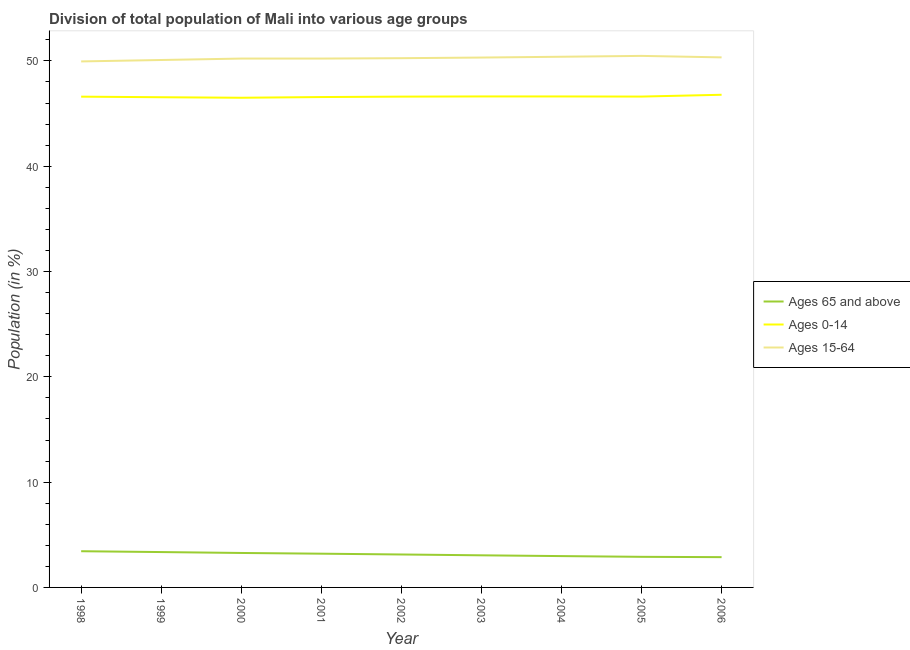Does the line corresponding to percentage of population within the age-group 0-14 intersect with the line corresponding to percentage of population within the age-group of 65 and above?
Provide a succinct answer. No. What is the percentage of population within the age-group of 65 and above in 2000?
Ensure brevity in your answer.  3.27. Across all years, what is the maximum percentage of population within the age-group 0-14?
Make the answer very short. 46.79. Across all years, what is the minimum percentage of population within the age-group 0-14?
Offer a very short reply. 46.5. In which year was the percentage of population within the age-group 15-64 minimum?
Keep it short and to the point. 1998. What is the total percentage of population within the age-group 0-14 in the graph?
Ensure brevity in your answer.  419.5. What is the difference between the percentage of population within the age-group 0-14 in 2005 and that in 2006?
Keep it short and to the point. -0.17. What is the difference between the percentage of population within the age-group 15-64 in 2004 and the percentage of population within the age-group of 65 and above in 1998?
Offer a terse response. 46.96. What is the average percentage of population within the age-group of 65 and above per year?
Give a very brief answer. 3.13. In the year 2003, what is the difference between the percentage of population within the age-group of 65 and above and percentage of population within the age-group 15-64?
Give a very brief answer. -47.27. In how many years, is the percentage of population within the age-group 0-14 greater than 36 %?
Keep it short and to the point. 9. What is the ratio of the percentage of population within the age-group 15-64 in 1999 to that in 2004?
Give a very brief answer. 0.99. Is the difference between the percentage of population within the age-group 15-64 in 2002 and 2006 greater than the difference between the percentage of population within the age-group of 65 and above in 2002 and 2006?
Offer a very short reply. No. What is the difference between the highest and the second highest percentage of population within the age-group 0-14?
Keep it short and to the point. 0.16. What is the difference between the highest and the lowest percentage of population within the age-group 15-64?
Keep it short and to the point. 0.53. In how many years, is the percentage of population within the age-group 15-64 greater than the average percentage of population within the age-group 15-64 taken over all years?
Keep it short and to the point. 5. Is it the case that in every year, the sum of the percentage of population within the age-group of 65 and above and percentage of population within the age-group 0-14 is greater than the percentage of population within the age-group 15-64?
Your response must be concise. No. How many years are there in the graph?
Give a very brief answer. 9. Are the values on the major ticks of Y-axis written in scientific E-notation?
Ensure brevity in your answer.  No. Where does the legend appear in the graph?
Ensure brevity in your answer.  Center right. How many legend labels are there?
Ensure brevity in your answer.  3. What is the title of the graph?
Give a very brief answer. Division of total population of Mali into various age groups
. What is the Population (in %) of Ages 65 and above in 1998?
Ensure brevity in your answer.  3.44. What is the Population (in %) in Ages 0-14 in 1998?
Ensure brevity in your answer.  46.61. What is the Population (in %) in Ages 15-64 in 1998?
Offer a very short reply. 49.95. What is the Population (in %) of Ages 65 and above in 1999?
Make the answer very short. 3.36. What is the Population (in %) in Ages 0-14 in 1999?
Your answer should be very brief. 46.55. What is the Population (in %) in Ages 15-64 in 1999?
Ensure brevity in your answer.  50.09. What is the Population (in %) in Ages 65 and above in 2000?
Ensure brevity in your answer.  3.27. What is the Population (in %) in Ages 0-14 in 2000?
Your answer should be very brief. 46.5. What is the Population (in %) in Ages 15-64 in 2000?
Ensure brevity in your answer.  50.23. What is the Population (in %) of Ages 65 and above in 2001?
Your response must be concise. 3.2. What is the Population (in %) of Ages 0-14 in 2001?
Provide a succinct answer. 46.57. What is the Population (in %) in Ages 15-64 in 2001?
Make the answer very short. 50.22. What is the Population (in %) in Ages 65 and above in 2002?
Provide a short and direct response. 3.13. What is the Population (in %) of Ages 0-14 in 2002?
Give a very brief answer. 46.61. What is the Population (in %) in Ages 15-64 in 2002?
Provide a succinct answer. 50.26. What is the Population (in %) of Ages 65 and above in 2003?
Offer a very short reply. 3.05. What is the Population (in %) in Ages 0-14 in 2003?
Provide a short and direct response. 46.63. What is the Population (in %) in Ages 15-64 in 2003?
Offer a very short reply. 50.32. What is the Population (in %) of Ages 65 and above in 2004?
Your answer should be compact. 2.98. What is the Population (in %) in Ages 0-14 in 2004?
Give a very brief answer. 46.63. What is the Population (in %) in Ages 15-64 in 2004?
Your answer should be very brief. 50.4. What is the Population (in %) in Ages 65 and above in 2005?
Your answer should be very brief. 2.91. What is the Population (in %) in Ages 0-14 in 2005?
Keep it short and to the point. 46.61. What is the Population (in %) in Ages 15-64 in 2005?
Offer a terse response. 50.48. What is the Population (in %) in Ages 65 and above in 2006?
Ensure brevity in your answer.  2.88. What is the Population (in %) of Ages 0-14 in 2006?
Offer a very short reply. 46.79. What is the Population (in %) of Ages 15-64 in 2006?
Your answer should be compact. 50.34. Across all years, what is the maximum Population (in %) in Ages 65 and above?
Provide a short and direct response. 3.44. Across all years, what is the maximum Population (in %) in Ages 0-14?
Your response must be concise. 46.79. Across all years, what is the maximum Population (in %) in Ages 15-64?
Keep it short and to the point. 50.48. Across all years, what is the minimum Population (in %) in Ages 65 and above?
Offer a very short reply. 2.88. Across all years, what is the minimum Population (in %) in Ages 0-14?
Provide a short and direct response. 46.5. Across all years, what is the minimum Population (in %) of Ages 15-64?
Provide a succinct answer. 49.95. What is the total Population (in %) in Ages 65 and above in the graph?
Your response must be concise. 28.21. What is the total Population (in %) of Ages 0-14 in the graph?
Offer a terse response. 419.5. What is the total Population (in %) of Ages 15-64 in the graph?
Give a very brief answer. 452.29. What is the difference between the Population (in %) in Ages 65 and above in 1998 and that in 1999?
Provide a succinct answer. 0.08. What is the difference between the Population (in %) of Ages 0-14 in 1998 and that in 1999?
Your response must be concise. 0.05. What is the difference between the Population (in %) of Ages 15-64 in 1998 and that in 1999?
Ensure brevity in your answer.  -0.13. What is the difference between the Population (in %) in Ages 65 and above in 1998 and that in 2000?
Make the answer very short. 0.17. What is the difference between the Population (in %) in Ages 0-14 in 1998 and that in 2000?
Your answer should be very brief. 0.1. What is the difference between the Population (in %) of Ages 15-64 in 1998 and that in 2000?
Make the answer very short. -0.27. What is the difference between the Population (in %) of Ages 65 and above in 1998 and that in 2001?
Keep it short and to the point. 0.23. What is the difference between the Population (in %) in Ages 0-14 in 1998 and that in 2001?
Give a very brief answer. 0.04. What is the difference between the Population (in %) of Ages 15-64 in 1998 and that in 2001?
Keep it short and to the point. -0.27. What is the difference between the Population (in %) of Ages 65 and above in 1998 and that in 2002?
Provide a succinct answer. 0.31. What is the difference between the Population (in %) in Ages 0-14 in 1998 and that in 2002?
Offer a very short reply. -0. What is the difference between the Population (in %) in Ages 15-64 in 1998 and that in 2002?
Your answer should be very brief. -0.31. What is the difference between the Population (in %) in Ages 65 and above in 1998 and that in 2003?
Your response must be concise. 0.39. What is the difference between the Population (in %) of Ages 0-14 in 1998 and that in 2003?
Make the answer very short. -0.02. What is the difference between the Population (in %) of Ages 15-64 in 1998 and that in 2003?
Your answer should be compact. -0.37. What is the difference between the Population (in %) of Ages 65 and above in 1998 and that in 2004?
Provide a short and direct response. 0.46. What is the difference between the Population (in %) in Ages 0-14 in 1998 and that in 2004?
Ensure brevity in your answer.  -0.02. What is the difference between the Population (in %) in Ages 15-64 in 1998 and that in 2004?
Make the answer very short. -0.44. What is the difference between the Population (in %) of Ages 65 and above in 1998 and that in 2005?
Provide a succinct answer. 0.53. What is the difference between the Population (in %) of Ages 0-14 in 1998 and that in 2005?
Give a very brief answer. -0.01. What is the difference between the Population (in %) in Ages 15-64 in 1998 and that in 2005?
Give a very brief answer. -0.53. What is the difference between the Population (in %) in Ages 65 and above in 1998 and that in 2006?
Your answer should be very brief. 0.56. What is the difference between the Population (in %) in Ages 0-14 in 1998 and that in 2006?
Give a very brief answer. -0.18. What is the difference between the Population (in %) in Ages 15-64 in 1998 and that in 2006?
Your answer should be very brief. -0.38. What is the difference between the Population (in %) of Ages 65 and above in 1999 and that in 2000?
Your response must be concise. 0.09. What is the difference between the Population (in %) of Ages 0-14 in 1999 and that in 2000?
Give a very brief answer. 0.05. What is the difference between the Population (in %) in Ages 15-64 in 1999 and that in 2000?
Your response must be concise. -0.14. What is the difference between the Population (in %) of Ages 65 and above in 1999 and that in 2001?
Your answer should be very brief. 0.15. What is the difference between the Population (in %) of Ages 0-14 in 1999 and that in 2001?
Make the answer very short. -0.02. What is the difference between the Population (in %) in Ages 15-64 in 1999 and that in 2001?
Your answer should be very brief. -0.14. What is the difference between the Population (in %) in Ages 65 and above in 1999 and that in 2002?
Give a very brief answer. 0.23. What is the difference between the Population (in %) of Ages 0-14 in 1999 and that in 2002?
Offer a terse response. -0.06. What is the difference between the Population (in %) of Ages 15-64 in 1999 and that in 2002?
Your response must be concise. -0.17. What is the difference between the Population (in %) of Ages 65 and above in 1999 and that in 2003?
Give a very brief answer. 0.31. What is the difference between the Population (in %) in Ages 0-14 in 1999 and that in 2003?
Keep it short and to the point. -0.07. What is the difference between the Population (in %) of Ages 15-64 in 1999 and that in 2003?
Provide a short and direct response. -0.23. What is the difference between the Population (in %) of Ages 65 and above in 1999 and that in 2004?
Your answer should be compact. 0.38. What is the difference between the Population (in %) of Ages 0-14 in 1999 and that in 2004?
Your response must be concise. -0.07. What is the difference between the Population (in %) of Ages 15-64 in 1999 and that in 2004?
Keep it short and to the point. -0.31. What is the difference between the Population (in %) in Ages 65 and above in 1999 and that in 2005?
Make the answer very short. 0.45. What is the difference between the Population (in %) of Ages 0-14 in 1999 and that in 2005?
Your answer should be very brief. -0.06. What is the difference between the Population (in %) in Ages 15-64 in 1999 and that in 2005?
Give a very brief answer. -0.39. What is the difference between the Population (in %) of Ages 65 and above in 1999 and that in 2006?
Your answer should be compact. 0.48. What is the difference between the Population (in %) of Ages 0-14 in 1999 and that in 2006?
Provide a short and direct response. -0.23. What is the difference between the Population (in %) of Ages 15-64 in 1999 and that in 2006?
Offer a very short reply. -0.25. What is the difference between the Population (in %) in Ages 65 and above in 2000 and that in 2001?
Provide a succinct answer. 0.07. What is the difference between the Population (in %) of Ages 0-14 in 2000 and that in 2001?
Offer a terse response. -0.07. What is the difference between the Population (in %) in Ages 15-64 in 2000 and that in 2001?
Your answer should be very brief. 0. What is the difference between the Population (in %) in Ages 65 and above in 2000 and that in 2002?
Provide a short and direct response. 0.14. What is the difference between the Population (in %) of Ages 0-14 in 2000 and that in 2002?
Offer a very short reply. -0.11. What is the difference between the Population (in %) of Ages 15-64 in 2000 and that in 2002?
Ensure brevity in your answer.  -0.04. What is the difference between the Population (in %) in Ages 65 and above in 2000 and that in 2003?
Provide a succinct answer. 0.22. What is the difference between the Population (in %) of Ages 0-14 in 2000 and that in 2003?
Offer a very short reply. -0.13. What is the difference between the Population (in %) of Ages 15-64 in 2000 and that in 2003?
Provide a short and direct response. -0.1. What is the difference between the Population (in %) of Ages 65 and above in 2000 and that in 2004?
Your response must be concise. 0.3. What is the difference between the Population (in %) of Ages 0-14 in 2000 and that in 2004?
Ensure brevity in your answer.  -0.12. What is the difference between the Population (in %) of Ages 15-64 in 2000 and that in 2004?
Give a very brief answer. -0.17. What is the difference between the Population (in %) in Ages 65 and above in 2000 and that in 2005?
Keep it short and to the point. 0.37. What is the difference between the Population (in %) in Ages 0-14 in 2000 and that in 2005?
Your response must be concise. -0.11. What is the difference between the Population (in %) in Ages 15-64 in 2000 and that in 2005?
Your response must be concise. -0.25. What is the difference between the Population (in %) of Ages 65 and above in 2000 and that in 2006?
Keep it short and to the point. 0.4. What is the difference between the Population (in %) of Ages 0-14 in 2000 and that in 2006?
Provide a short and direct response. -0.28. What is the difference between the Population (in %) in Ages 15-64 in 2000 and that in 2006?
Your response must be concise. -0.11. What is the difference between the Population (in %) of Ages 65 and above in 2001 and that in 2002?
Your answer should be very brief. 0.08. What is the difference between the Population (in %) of Ages 0-14 in 2001 and that in 2002?
Offer a very short reply. -0.04. What is the difference between the Population (in %) of Ages 15-64 in 2001 and that in 2002?
Make the answer very short. -0.04. What is the difference between the Population (in %) of Ages 65 and above in 2001 and that in 2003?
Give a very brief answer. 0.15. What is the difference between the Population (in %) in Ages 0-14 in 2001 and that in 2003?
Keep it short and to the point. -0.06. What is the difference between the Population (in %) of Ages 15-64 in 2001 and that in 2003?
Your response must be concise. -0.1. What is the difference between the Population (in %) of Ages 65 and above in 2001 and that in 2004?
Offer a very short reply. 0.23. What is the difference between the Population (in %) in Ages 0-14 in 2001 and that in 2004?
Ensure brevity in your answer.  -0.06. What is the difference between the Population (in %) of Ages 15-64 in 2001 and that in 2004?
Give a very brief answer. -0.17. What is the difference between the Population (in %) in Ages 65 and above in 2001 and that in 2005?
Provide a short and direct response. 0.3. What is the difference between the Population (in %) of Ages 0-14 in 2001 and that in 2005?
Make the answer very short. -0.04. What is the difference between the Population (in %) in Ages 15-64 in 2001 and that in 2005?
Ensure brevity in your answer.  -0.25. What is the difference between the Population (in %) in Ages 65 and above in 2001 and that in 2006?
Offer a very short reply. 0.33. What is the difference between the Population (in %) of Ages 0-14 in 2001 and that in 2006?
Your answer should be compact. -0.22. What is the difference between the Population (in %) in Ages 15-64 in 2001 and that in 2006?
Offer a very short reply. -0.11. What is the difference between the Population (in %) of Ages 65 and above in 2002 and that in 2003?
Your response must be concise. 0.08. What is the difference between the Population (in %) in Ages 0-14 in 2002 and that in 2003?
Provide a short and direct response. -0.02. What is the difference between the Population (in %) in Ages 15-64 in 2002 and that in 2003?
Keep it short and to the point. -0.06. What is the difference between the Population (in %) in Ages 65 and above in 2002 and that in 2004?
Offer a terse response. 0.15. What is the difference between the Population (in %) in Ages 0-14 in 2002 and that in 2004?
Offer a very short reply. -0.02. What is the difference between the Population (in %) in Ages 15-64 in 2002 and that in 2004?
Provide a succinct answer. -0.14. What is the difference between the Population (in %) of Ages 65 and above in 2002 and that in 2005?
Ensure brevity in your answer.  0.22. What is the difference between the Population (in %) of Ages 0-14 in 2002 and that in 2005?
Your answer should be very brief. -0. What is the difference between the Population (in %) in Ages 15-64 in 2002 and that in 2005?
Give a very brief answer. -0.22. What is the difference between the Population (in %) in Ages 65 and above in 2002 and that in 2006?
Your answer should be compact. 0.25. What is the difference between the Population (in %) in Ages 0-14 in 2002 and that in 2006?
Provide a short and direct response. -0.18. What is the difference between the Population (in %) of Ages 15-64 in 2002 and that in 2006?
Make the answer very short. -0.08. What is the difference between the Population (in %) of Ages 65 and above in 2003 and that in 2004?
Ensure brevity in your answer.  0.08. What is the difference between the Population (in %) of Ages 0-14 in 2003 and that in 2004?
Ensure brevity in your answer.  0. What is the difference between the Population (in %) of Ages 15-64 in 2003 and that in 2004?
Your response must be concise. -0.08. What is the difference between the Population (in %) of Ages 65 and above in 2003 and that in 2005?
Provide a succinct answer. 0.14. What is the difference between the Population (in %) in Ages 0-14 in 2003 and that in 2005?
Ensure brevity in your answer.  0.01. What is the difference between the Population (in %) of Ages 15-64 in 2003 and that in 2005?
Give a very brief answer. -0.16. What is the difference between the Population (in %) of Ages 65 and above in 2003 and that in 2006?
Your answer should be compact. 0.17. What is the difference between the Population (in %) in Ages 0-14 in 2003 and that in 2006?
Your answer should be very brief. -0.16. What is the difference between the Population (in %) in Ages 15-64 in 2003 and that in 2006?
Offer a terse response. -0.02. What is the difference between the Population (in %) of Ages 65 and above in 2004 and that in 2005?
Your response must be concise. 0.07. What is the difference between the Population (in %) of Ages 0-14 in 2004 and that in 2005?
Give a very brief answer. 0.01. What is the difference between the Population (in %) of Ages 15-64 in 2004 and that in 2005?
Your response must be concise. -0.08. What is the difference between the Population (in %) in Ages 65 and above in 2004 and that in 2006?
Your answer should be very brief. 0.1. What is the difference between the Population (in %) in Ages 0-14 in 2004 and that in 2006?
Give a very brief answer. -0.16. What is the difference between the Population (in %) of Ages 15-64 in 2004 and that in 2006?
Offer a terse response. 0.06. What is the difference between the Population (in %) in Ages 65 and above in 2005 and that in 2006?
Your answer should be compact. 0.03. What is the difference between the Population (in %) of Ages 0-14 in 2005 and that in 2006?
Keep it short and to the point. -0.17. What is the difference between the Population (in %) of Ages 15-64 in 2005 and that in 2006?
Give a very brief answer. 0.14. What is the difference between the Population (in %) of Ages 65 and above in 1998 and the Population (in %) of Ages 0-14 in 1999?
Provide a short and direct response. -43.11. What is the difference between the Population (in %) of Ages 65 and above in 1998 and the Population (in %) of Ages 15-64 in 1999?
Your response must be concise. -46.65. What is the difference between the Population (in %) of Ages 0-14 in 1998 and the Population (in %) of Ages 15-64 in 1999?
Your response must be concise. -3.48. What is the difference between the Population (in %) of Ages 65 and above in 1998 and the Population (in %) of Ages 0-14 in 2000?
Your answer should be very brief. -43.06. What is the difference between the Population (in %) in Ages 65 and above in 1998 and the Population (in %) in Ages 15-64 in 2000?
Give a very brief answer. -46.79. What is the difference between the Population (in %) in Ages 0-14 in 1998 and the Population (in %) in Ages 15-64 in 2000?
Provide a short and direct response. -3.62. What is the difference between the Population (in %) in Ages 65 and above in 1998 and the Population (in %) in Ages 0-14 in 2001?
Make the answer very short. -43.13. What is the difference between the Population (in %) in Ages 65 and above in 1998 and the Population (in %) in Ages 15-64 in 2001?
Your answer should be compact. -46.79. What is the difference between the Population (in %) in Ages 0-14 in 1998 and the Population (in %) in Ages 15-64 in 2001?
Your answer should be compact. -3.62. What is the difference between the Population (in %) of Ages 65 and above in 1998 and the Population (in %) of Ages 0-14 in 2002?
Your answer should be very brief. -43.17. What is the difference between the Population (in %) in Ages 65 and above in 1998 and the Population (in %) in Ages 15-64 in 2002?
Give a very brief answer. -46.82. What is the difference between the Population (in %) of Ages 0-14 in 1998 and the Population (in %) of Ages 15-64 in 2002?
Your response must be concise. -3.65. What is the difference between the Population (in %) of Ages 65 and above in 1998 and the Population (in %) of Ages 0-14 in 2003?
Make the answer very short. -43.19. What is the difference between the Population (in %) in Ages 65 and above in 1998 and the Population (in %) in Ages 15-64 in 2003?
Provide a succinct answer. -46.88. What is the difference between the Population (in %) in Ages 0-14 in 1998 and the Population (in %) in Ages 15-64 in 2003?
Provide a succinct answer. -3.71. What is the difference between the Population (in %) in Ages 65 and above in 1998 and the Population (in %) in Ages 0-14 in 2004?
Your response must be concise. -43.19. What is the difference between the Population (in %) in Ages 65 and above in 1998 and the Population (in %) in Ages 15-64 in 2004?
Your answer should be very brief. -46.96. What is the difference between the Population (in %) of Ages 0-14 in 1998 and the Population (in %) of Ages 15-64 in 2004?
Ensure brevity in your answer.  -3.79. What is the difference between the Population (in %) of Ages 65 and above in 1998 and the Population (in %) of Ages 0-14 in 2005?
Ensure brevity in your answer.  -43.18. What is the difference between the Population (in %) of Ages 65 and above in 1998 and the Population (in %) of Ages 15-64 in 2005?
Provide a short and direct response. -47.04. What is the difference between the Population (in %) of Ages 0-14 in 1998 and the Population (in %) of Ages 15-64 in 2005?
Your answer should be very brief. -3.87. What is the difference between the Population (in %) in Ages 65 and above in 1998 and the Population (in %) in Ages 0-14 in 2006?
Your response must be concise. -43.35. What is the difference between the Population (in %) in Ages 65 and above in 1998 and the Population (in %) in Ages 15-64 in 2006?
Your response must be concise. -46.9. What is the difference between the Population (in %) of Ages 0-14 in 1998 and the Population (in %) of Ages 15-64 in 2006?
Provide a short and direct response. -3.73. What is the difference between the Population (in %) in Ages 65 and above in 1999 and the Population (in %) in Ages 0-14 in 2000?
Provide a succinct answer. -43.14. What is the difference between the Population (in %) of Ages 65 and above in 1999 and the Population (in %) of Ages 15-64 in 2000?
Your answer should be very brief. -46.87. What is the difference between the Population (in %) of Ages 0-14 in 1999 and the Population (in %) of Ages 15-64 in 2000?
Your answer should be very brief. -3.67. What is the difference between the Population (in %) of Ages 65 and above in 1999 and the Population (in %) of Ages 0-14 in 2001?
Your answer should be very brief. -43.21. What is the difference between the Population (in %) in Ages 65 and above in 1999 and the Population (in %) in Ages 15-64 in 2001?
Give a very brief answer. -46.87. What is the difference between the Population (in %) in Ages 0-14 in 1999 and the Population (in %) in Ages 15-64 in 2001?
Give a very brief answer. -3.67. What is the difference between the Population (in %) in Ages 65 and above in 1999 and the Population (in %) in Ages 0-14 in 2002?
Offer a terse response. -43.25. What is the difference between the Population (in %) in Ages 65 and above in 1999 and the Population (in %) in Ages 15-64 in 2002?
Your answer should be very brief. -46.9. What is the difference between the Population (in %) in Ages 0-14 in 1999 and the Population (in %) in Ages 15-64 in 2002?
Offer a very short reply. -3.71. What is the difference between the Population (in %) in Ages 65 and above in 1999 and the Population (in %) in Ages 0-14 in 2003?
Keep it short and to the point. -43.27. What is the difference between the Population (in %) in Ages 65 and above in 1999 and the Population (in %) in Ages 15-64 in 2003?
Provide a short and direct response. -46.96. What is the difference between the Population (in %) in Ages 0-14 in 1999 and the Population (in %) in Ages 15-64 in 2003?
Ensure brevity in your answer.  -3.77. What is the difference between the Population (in %) in Ages 65 and above in 1999 and the Population (in %) in Ages 0-14 in 2004?
Provide a short and direct response. -43.27. What is the difference between the Population (in %) in Ages 65 and above in 1999 and the Population (in %) in Ages 15-64 in 2004?
Ensure brevity in your answer.  -47.04. What is the difference between the Population (in %) in Ages 0-14 in 1999 and the Population (in %) in Ages 15-64 in 2004?
Offer a terse response. -3.84. What is the difference between the Population (in %) in Ages 65 and above in 1999 and the Population (in %) in Ages 0-14 in 2005?
Provide a succinct answer. -43.26. What is the difference between the Population (in %) of Ages 65 and above in 1999 and the Population (in %) of Ages 15-64 in 2005?
Offer a very short reply. -47.12. What is the difference between the Population (in %) of Ages 0-14 in 1999 and the Population (in %) of Ages 15-64 in 2005?
Ensure brevity in your answer.  -3.93. What is the difference between the Population (in %) of Ages 65 and above in 1999 and the Population (in %) of Ages 0-14 in 2006?
Keep it short and to the point. -43.43. What is the difference between the Population (in %) in Ages 65 and above in 1999 and the Population (in %) in Ages 15-64 in 2006?
Your response must be concise. -46.98. What is the difference between the Population (in %) of Ages 0-14 in 1999 and the Population (in %) of Ages 15-64 in 2006?
Your answer should be very brief. -3.78. What is the difference between the Population (in %) of Ages 65 and above in 2000 and the Population (in %) of Ages 0-14 in 2001?
Provide a short and direct response. -43.3. What is the difference between the Population (in %) in Ages 65 and above in 2000 and the Population (in %) in Ages 15-64 in 2001?
Provide a short and direct response. -46.95. What is the difference between the Population (in %) in Ages 0-14 in 2000 and the Population (in %) in Ages 15-64 in 2001?
Your response must be concise. -3.72. What is the difference between the Population (in %) of Ages 65 and above in 2000 and the Population (in %) of Ages 0-14 in 2002?
Your answer should be compact. -43.34. What is the difference between the Population (in %) of Ages 65 and above in 2000 and the Population (in %) of Ages 15-64 in 2002?
Provide a short and direct response. -46.99. What is the difference between the Population (in %) in Ages 0-14 in 2000 and the Population (in %) in Ages 15-64 in 2002?
Ensure brevity in your answer.  -3.76. What is the difference between the Population (in %) of Ages 65 and above in 2000 and the Population (in %) of Ages 0-14 in 2003?
Your answer should be compact. -43.36. What is the difference between the Population (in %) in Ages 65 and above in 2000 and the Population (in %) in Ages 15-64 in 2003?
Make the answer very short. -47.05. What is the difference between the Population (in %) of Ages 0-14 in 2000 and the Population (in %) of Ages 15-64 in 2003?
Provide a succinct answer. -3.82. What is the difference between the Population (in %) of Ages 65 and above in 2000 and the Population (in %) of Ages 0-14 in 2004?
Make the answer very short. -43.36. What is the difference between the Population (in %) in Ages 65 and above in 2000 and the Population (in %) in Ages 15-64 in 2004?
Provide a short and direct response. -47.13. What is the difference between the Population (in %) of Ages 0-14 in 2000 and the Population (in %) of Ages 15-64 in 2004?
Your response must be concise. -3.89. What is the difference between the Population (in %) of Ages 65 and above in 2000 and the Population (in %) of Ages 0-14 in 2005?
Provide a short and direct response. -43.34. What is the difference between the Population (in %) of Ages 65 and above in 2000 and the Population (in %) of Ages 15-64 in 2005?
Keep it short and to the point. -47.21. What is the difference between the Population (in %) of Ages 0-14 in 2000 and the Population (in %) of Ages 15-64 in 2005?
Give a very brief answer. -3.98. What is the difference between the Population (in %) in Ages 65 and above in 2000 and the Population (in %) in Ages 0-14 in 2006?
Ensure brevity in your answer.  -43.52. What is the difference between the Population (in %) of Ages 65 and above in 2000 and the Population (in %) of Ages 15-64 in 2006?
Provide a succinct answer. -47.07. What is the difference between the Population (in %) of Ages 0-14 in 2000 and the Population (in %) of Ages 15-64 in 2006?
Your response must be concise. -3.83. What is the difference between the Population (in %) of Ages 65 and above in 2001 and the Population (in %) of Ages 0-14 in 2002?
Make the answer very short. -43.41. What is the difference between the Population (in %) of Ages 65 and above in 2001 and the Population (in %) of Ages 15-64 in 2002?
Your response must be concise. -47.06. What is the difference between the Population (in %) in Ages 0-14 in 2001 and the Population (in %) in Ages 15-64 in 2002?
Ensure brevity in your answer.  -3.69. What is the difference between the Population (in %) of Ages 65 and above in 2001 and the Population (in %) of Ages 0-14 in 2003?
Offer a very short reply. -43.42. What is the difference between the Population (in %) in Ages 65 and above in 2001 and the Population (in %) in Ages 15-64 in 2003?
Offer a very short reply. -47.12. What is the difference between the Population (in %) of Ages 0-14 in 2001 and the Population (in %) of Ages 15-64 in 2003?
Make the answer very short. -3.75. What is the difference between the Population (in %) in Ages 65 and above in 2001 and the Population (in %) in Ages 0-14 in 2004?
Your answer should be very brief. -43.42. What is the difference between the Population (in %) of Ages 65 and above in 2001 and the Population (in %) of Ages 15-64 in 2004?
Give a very brief answer. -47.19. What is the difference between the Population (in %) in Ages 0-14 in 2001 and the Population (in %) in Ages 15-64 in 2004?
Make the answer very short. -3.83. What is the difference between the Population (in %) in Ages 65 and above in 2001 and the Population (in %) in Ages 0-14 in 2005?
Your answer should be compact. -43.41. What is the difference between the Population (in %) in Ages 65 and above in 2001 and the Population (in %) in Ages 15-64 in 2005?
Ensure brevity in your answer.  -47.27. What is the difference between the Population (in %) of Ages 0-14 in 2001 and the Population (in %) of Ages 15-64 in 2005?
Keep it short and to the point. -3.91. What is the difference between the Population (in %) of Ages 65 and above in 2001 and the Population (in %) of Ages 0-14 in 2006?
Make the answer very short. -43.58. What is the difference between the Population (in %) in Ages 65 and above in 2001 and the Population (in %) in Ages 15-64 in 2006?
Your answer should be very brief. -47.13. What is the difference between the Population (in %) in Ages 0-14 in 2001 and the Population (in %) in Ages 15-64 in 2006?
Keep it short and to the point. -3.77. What is the difference between the Population (in %) in Ages 65 and above in 2002 and the Population (in %) in Ages 0-14 in 2003?
Provide a short and direct response. -43.5. What is the difference between the Population (in %) of Ages 65 and above in 2002 and the Population (in %) of Ages 15-64 in 2003?
Your answer should be compact. -47.19. What is the difference between the Population (in %) in Ages 0-14 in 2002 and the Population (in %) in Ages 15-64 in 2003?
Keep it short and to the point. -3.71. What is the difference between the Population (in %) in Ages 65 and above in 2002 and the Population (in %) in Ages 0-14 in 2004?
Your answer should be compact. -43.5. What is the difference between the Population (in %) of Ages 65 and above in 2002 and the Population (in %) of Ages 15-64 in 2004?
Offer a terse response. -47.27. What is the difference between the Population (in %) of Ages 0-14 in 2002 and the Population (in %) of Ages 15-64 in 2004?
Your response must be concise. -3.79. What is the difference between the Population (in %) of Ages 65 and above in 2002 and the Population (in %) of Ages 0-14 in 2005?
Provide a short and direct response. -43.49. What is the difference between the Population (in %) in Ages 65 and above in 2002 and the Population (in %) in Ages 15-64 in 2005?
Offer a terse response. -47.35. What is the difference between the Population (in %) of Ages 0-14 in 2002 and the Population (in %) of Ages 15-64 in 2005?
Your response must be concise. -3.87. What is the difference between the Population (in %) in Ages 65 and above in 2002 and the Population (in %) in Ages 0-14 in 2006?
Your response must be concise. -43.66. What is the difference between the Population (in %) of Ages 65 and above in 2002 and the Population (in %) of Ages 15-64 in 2006?
Make the answer very short. -47.21. What is the difference between the Population (in %) of Ages 0-14 in 2002 and the Population (in %) of Ages 15-64 in 2006?
Your answer should be very brief. -3.73. What is the difference between the Population (in %) of Ages 65 and above in 2003 and the Population (in %) of Ages 0-14 in 2004?
Keep it short and to the point. -43.58. What is the difference between the Population (in %) of Ages 65 and above in 2003 and the Population (in %) of Ages 15-64 in 2004?
Give a very brief answer. -47.35. What is the difference between the Population (in %) of Ages 0-14 in 2003 and the Population (in %) of Ages 15-64 in 2004?
Provide a short and direct response. -3.77. What is the difference between the Population (in %) in Ages 65 and above in 2003 and the Population (in %) in Ages 0-14 in 2005?
Your answer should be compact. -43.56. What is the difference between the Population (in %) of Ages 65 and above in 2003 and the Population (in %) of Ages 15-64 in 2005?
Provide a short and direct response. -47.43. What is the difference between the Population (in %) in Ages 0-14 in 2003 and the Population (in %) in Ages 15-64 in 2005?
Your answer should be compact. -3.85. What is the difference between the Population (in %) of Ages 65 and above in 2003 and the Population (in %) of Ages 0-14 in 2006?
Your response must be concise. -43.74. What is the difference between the Population (in %) in Ages 65 and above in 2003 and the Population (in %) in Ages 15-64 in 2006?
Your response must be concise. -47.29. What is the difference between the Population (in %) in Ages 0-14 in 2003 and the Population (in %) in Ages 15-64 in 2006?
Your response must be concise. -3.71. What is the difference between the Population (in %) in Ages 65 and above in 2004 and the Population (in %) in Ages 0-14 in 2005?
Offer a terse response. -43.64. What is the difference between the Population (in %) in Ages 65 and above in 2004 and the Population (in %) in Ages 15-64 in 2005?
Offer a terse response. -47.5. What is the difference between the Population (in %) of Ages 0-14 in 2004 and the Population (in %) of Ages 15-64 in 2005?
Offer a terse response. -3.85. What is the difference between the Population (in %) of Ages 65 and above in 2004 and the Population (in %) of Ages 0-14 in 2006?
Your response must be concise. -43.81. What is the difference between the Population (in %) in Ages 65 and above in 2004 and the Population (in %) in Ages 15-64 in 2006?
Your answer should be compact. -47.36. What is the difference between the Population (in %) of Ages 0-14 in 2004 and the Population (in %) of Ages 15-64 in 2006?
Keep it short and to the point. -3.71. What is the difference between the Population (in %) of Ages 65 and above in 2005 and the Population (in %) of Ages 0-14 in 2006?
Provide a short and direct response. -43.88. What is the difference between the Population (in %) of Ages 65 and above in 2005 and the Population (in %) of Ages 15-64 in 2006?
Your response must be concise. -47.43. What is the difference between the Population (in %) of Ages 0-14 in 2005 and the Population (in %) of Ages 15-64 in 2006?
Offer a terse response. -3.72. What is the average Population (in %) in Ages 65 and above per year?
Your response must be concise. 3.13. What is the average Population (in %) of Ages 0-14 per year?
Your answer should be compact. 46.61. What is the average Population (in %) in Ages 15-64 per year?
Your answer should be very brief. 50.25. In the year 1998, what is the difference between the Population (in %) of Ages 65 and above and Population (in %) of Ages 0-14?
Offer a very short reply. -43.17. In the year 1998, what is the difference between the Population (in %) in Ages 65 and above and Population (in %) in Ages 15-64?
Keep it short and to the point. -46.52. In the year 1998, what is the difference between the Population (in %) in Ages 0-14 and Population (in %) in Ages 15-64?
Keep it short and to the point. -3.35. In the year 1999, what is the difference between the Population (in %) of Ages 65 and above and Population (in %) of Ages 0-14?
Ensure brevity in your answer.  -43.19. In the year 1999, what is the difference between the Population (in %) in Ages 65 and above and Population (in %) in Ages 15-64?
Your answer should be very brief. -46.73. In the year 1999, what is the difference between the Population (in %) of Ages 0-14 and Population (in %) of Ages 15-64?
Offer a very short reply. -3.54. In the year 2000, what is the difference between the Population (in %) in Ages 65 and above and Population (in %) in Ages 0-14?
Give a very brief answer. -43.23. In the year 2000, what is the difference between the Population (in %) of Ages 65 and above and Population (in %) of Ages 15-64?
Offer a very short reply. -46.95. In the year 2000, what is the difference between the Population (in %) in Ages 0-14 and Population (in %) in Ages 15-64?
Your response must be concise. -3.72. In the year 2001, what is the difference between the Population (in %) in Ages 65 and above and Population (in %) in Ages 0-14?
Give a very brief answer. -43.37. In the year 2001, what is the difference between the Population (in %) in Ages 65 and above and Population (in %) in Ages 15-64?
Keep it short and to the point. -47.02. In the year 2001, what is the difference between the Population (in %) in Ages 0-14 and Population (in %) in Ages 15-64?
Your answer should be very brief. -3.65. In the year 2002, what is the difference between the Population (in %) of Ages 65 and above and Population (in %) of Ages 0-14?
Offer a terse response. -43.48. In the year 2002, what is the difference between the Population (in %) of Ages 65 and above and Population (in %) of Ages 15-64?
Keep it short and to the point. -47.13. In the year 2002, what is the difference between the Population (in %) of Ages 0-14 and Population (in %) of Ages 15-64?
Keep it short and to the point. -3.65. In the year 2003, what is the difference between the Population (in %) in Ages 65 and above and Population (in %) in Ages 0-14?
Offer a terse response. -43.58. In the year 2003, what is the difference between the Population (in %) of Ages 65 and above and Population (in %) of Ages 15-64?
Provide a short and direct response. -47.27. In the year 2003, what is the difference between the Population (in %) of Ages 0-14 and Population (in %) of Ages 15-64?
Make the answer very short. -3.69. In the year 2004, what is the difference between the Population (in %) of Ages 65 and above and Population (in %) of Ages 0-14?
Provide a succinct answer. -43.65. In the year 2004, what is the difference between the Population (in %) in Ages 65 and above and Population (in %) in Ages 15-64?
Make the answer very short. -47.42. In the year 2004, what is the difference between the Population (in %) of Ages 0-14 and Population (in %) of Ages 15-64?
Offer a very short reply. -3.77. In the year 2005, what is the difference between the Population (in %) of Ages 65 and above and Population (in %) of Ages 0-14?
Keep it short and to the point. -43.71. In the year 2005, what is the difference between the Population (in %) in Ages 65 and above and Population (in %) in Ages 15-64?
Offer a very short reply. -47.57. In the year 2005, what is the difference between the Population (in %) in Ages 0-14 and Population (in %) in Ages 15-64?
Offer a very short reply. -3.86. In the year 2006, what is the difference between the Population (in %) in Ages 65 and above and Population (in %) in Ages 0-14?
Your answer should be very brief. -43.91. In the year 2006, what is the difference between the Population (in %) of Ages 65 and above and Population (in %) of Ages 15-64?
Provide a succinct answer. -47.46. In the year 2006, what is the difference between the Population (in %) in Ages 0-14 and Population (in %) in Ages 15-64?
Your answer should be very brief. -3.55. What is the ratio of the Population (in %) of Ages 65 and above in 1998 to that in 1999?
Give a very brief answer. 1.02. What is the ratio of the Population (in %) in Ages 0-14 in 1998 to that in 1999?
Your answer should be very brief. 1. What is the ratio of the Population (in %) of Ages 15-64 in 1998 to that in 1999?
Keep it short and to the point. 1. What is the ratio of the Population (in %) of Ages 65 and above in 1998 to that in 2000?
Offer a very short reply. 1.05. What is the ratio of the Population (in %) of Ages 15-64 in 1998 to that in 2000?
Offer a very short reply. 0.99. What is the ratio of the Population (in %) in Ages 65 and above in 1998 to that in 2001?
Keep it short and to the point. 1.07. What is the ratio of the Population (in %) of Ages 15-64 in 1998 to that in 2001?
Make the answer very short. 0.99. What is the ratio of the Population (in %) in Ages 65 and above in 1998 to that in 2002?
Make the answer very short. 1.1. What is the ratio of the Population (in %) in Ages 15-64 in 1998 to that in 2002?
Provide a short and direct response. 0.99. What is the ratio of the Population (in %) of Ages 65 and above in 1998 to that in 2003?
Offer a terse response. 1.13. What is the ratio of the Population (in %) in Ages 0-14 in 1998 to that in 2003?
Your answer should be compact. 1. What is the ratio of the Population (in %) in Ages 65 and above in 1998 to that in 2004?
Provide a short and direct response. 1.16. What is the ratio of the Population (in %) in Ages 0-14 in 1998 to that in 2004?
Give a very brief answer. 1. What is the ratio of the Population (in %) of Ages 65 and above in 1998 to that in 2005?
Provide a succinct answer. 1.18. What is the ratio of the Population (in %) in Ages 65 and above in 1998 to that in 2006?
Your response must be concise. 1.2. What is the ratio of the Population (in %) in Ages 65 and above in 1999 to that in 2000?
Offer a terse response. 1.03. What is the ratio of the Population (in %) of Ages 65 and above in 1999 to that in 2001?
Ensure brevity in your answer.  1.05. What is the ratio of the Population (in %) in Ages 0-14 in 1999 to that in 2001?
Make the answer very short. 1. What is the ratio of the Population (in %) in Ages 65 and above in 1999 to that in 2002?
Provide a short and direct response. 1.07. What is the ratio of the Population (in %) of Ages 0-14 in 1999 to that in 2002?
Give a very brief answer. 1. What is the ratio of the Population (in %) of Ages 65 and above in 1999 to that in 2003?
Keep it short and to the point. 1.1. What is the ratio of the Population (in %) in Ages 0-14 in 1999 to that in 2003?
Ensure brevity in your answer.  1. What is the ratio of the Population (in %) of Ages 15-64 in 1999 to that in 2003?
Your answer should be compact. 1. What is the ratio of the Population (in %) of Ages 65 and above in 1999 to that in 2004?
Your response must be concise. 1.13. What is the ratio of the Population (in %) in Ages 0-14 in 1999 to that in 2004?
Keep it short and to the point. 1. What is the ratio of the Population (in %) of Ages 15-64 in 1999 to that in 2004?
Ensure brevity in your answer.  0.99. What is the ratio of the Population (in %) of Ages 65 and above in 1999 to that in 2005?
Your answer should be very brief. 1.16. What is the ratio of the Population (in %) of Ages 0-14 in 1999 to that in 2005?
Your response must be concise. 1. What is the ratio of the Population (in %) in Ages 65 and above in 1999 to that in 2006?
Ensure brevity in your answer.  1.17. What is the ratio of the Population (in %) in Ages 15-64 in 1999 to that in 2006?
Provide a succinct answer. 1. What is the ratio of the Population (in %) of Ages 65 and above in 2000 to that in 2001?
Your answer should be compact. 1.02. What is the ratio of the Population (in %) of Ages 0-14 in 2000 to that in 2001?
Offer a terse response. 1. What is the ratio of the Population (in %) in Ages 15-64 in 2000 to that in 2001?
Offer a terse response. 1. What is the ratio of the Population (in %) of Ages 65 and above in 2000 to that in 2002?
Provide a short and direct response. 1.05. What is the ratio of the Population (in %) in Ages 65 and above in 2000 to that in 2003?
Your answer should be compact. 1.07. What is the ratio of the Population (in %) of Ages 65 and above in 2000 to that in 2004?
Offer a terse response. 1.1. What is the ratio of the Population (in %) of Ages 0-14 in 2000 to that in 2004?
Offer a very short reply. 1. What is the ratio of the Population (in %) of Ages 15-64 in 2000 to that in 2004?
Give a very brief answer. 1. What is the ratio of the Population (in %) in Ages 65 and above in 2000 to that in 2005?
Offer a very short reply. 1.13. What is the ratio of the Population (in %) in Ages 65 and above in 2000 to that in 2006?
Give a very brief answer. 1.14. What is the ratio of the Population (in %) in Ages 0-14 in 2000 to that in 2006?
Your answer should be compact. 0.99. What is the ratio of the Population (in %) in Ages 15-64 in 2000 to that in 2006?
Make the answer very short. 1. What is the ratio of the Population (in %) of Ages 65 and above in 2001 to that in 2002?
Offer a terse response. 1.02. What is the ratio of the Population (in %) in Ages 0-14 in 2001 to that in 2002?
Your answer should be compact. 1. What is the ratio of the Population (in %) in Ages 15-64 in 2001 to that in 2002?
Provide a short and direct response. 1. What is the ratio of the Population (in %) in Ages 65 and above in 2001 to that in 2003?
Your response must be concise. 1.05. What is the ratio of the Population (in %) of Ages 15-64 in 2001 to that in 2003?
Ensure brevity in your answer.  1. What is the ratio of the Population (in %) in Ages 65 and above in 2001 to that in 2004?
Keep it short and to the point. 1.08. What is the ratio of the Population (in %) in Ages 0-14 in 2001 to that in 2004?
Your answer should be very brief. 1. What is the ratio of the Population (in %) of Ages 15-64 in 2001 to that in 2004?
Keep it short and to the point. 1. What is the ratio of the Population (in %) of Ages 65 and above in 2001 to that in 2005?
Your answer should be compact. 1.1. What is the ratio of the Population (in %) in Ages 15-64 in 2001 to that in 2005?
Keep it short and to the point. 0.99. What is the ratio of the Population (in %) in Ages 65 and above in 2001 to that in 2006?
Offer a very short reply. 1.11. What is the ratio of the Population (in %) of Ages 65 and above in 2002 to that in 2003?
Offer a very short reply. 1.03. What is the ratio of the Population (in %) of Ages 15-64 in 2002 to that in 2003?
Your answer should be very brief. 1. What is the ratio of the Population (in %) in Ages 65 and above in 2002 to that in 2004?
Your answer should be compact. 1.05. What is the ratio of the Population (in %) in Ages 0-14 in 2002 to that in 2004?
Provide a succinct answer. 1. What is the ratio of the Population (in %) of Ages 65 and above in 2002 to that in 2005?
Ensure brevity in your answer.  1.08. What is the ratio of the Population (in %) of Ages 15-64 in 2002 to that in 2005?
Keep it short and to the point. 1. What is the ratio of the Population (in %) of Ages 65 and above in 2002 to that in 2006?
Your answer should be compact. 1.09. What is the ratio of the Population (in %) of Ages 0-14 in 2002 to that in 2006?
Ensure brevity in your answer.  1. What is the ratio of the Population (in %) in Ages 65 and above in 2003 to that in 2004?
Your answer should be compact. 1.03. What is the ratio of the Population (in %) of Ages 65 and above in 2003 to that in 2005?
Ensure brevity in your answer.  1.05. What is the ratio of the Population (in %) of Ages 65 and above in 2003 to that in 2006?
Offer a terse response. 1.06. What is the ratio of the Population (in %) of Ages 65 and above in 2004 to that in 2005?
Give a very brief answer. 1.02. What is the ratio of the Population (in %) of Ages 65 and above in 2004 to that in 2006?
Your answer should be compact. 1.03. What is the ratio of the Population (in %) in Ages 65 and above in 2005 to that in 2006?
Make the answer very short. 1.01. What is the ratio of the Population (in %) of Ages 15-64 in 2005 to that in 2006?
Make the answer very short. 1. What is the difference between the highest and the second highest Population (in %) of Ages 65 and above?
Give a very brief answer. 0.08. What is the difference between the highest and the second highest Population (in %) in Ages 0-14?
Make the answer very short. 0.16. What is the difference between the highest and the second highest Population (in %) of Ages 15-64?
Provide a succinct answer. 0.08. What is the difference between the highest and the lowest Population (in %) in Ages 65 and above?
Provide a short and direct response. 0.56. What is the difference between the highest and the lowest Population (in %) in Ages 0-14?
Give a very brief answer. 0.28. What is the difference between the highest and the lowest Population (in %) of Ages 15-64?
Ensure brevity in your answer.  0.53. 